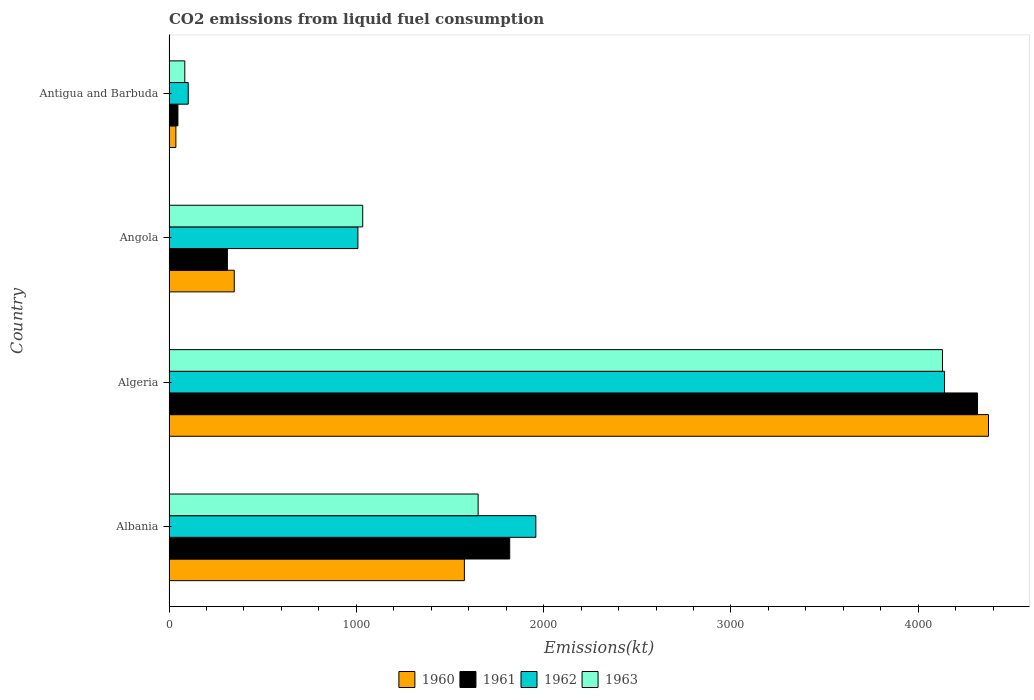How many different coloured bars are there?
Your response must be concise. 4. How many groups of bars are there?
Give a very brief answer. 4. What is the label of the 4th group of bars from the top?
Offer a terse response. Albania. What is the amount of CO2 emitted in 1960 in Albania?
Give a very brief answer. 1576.81. Across all countries, what is the maximum amount of CO2 emitted in 1960?
Your answer should be very brief. 4374.73. Across all countries, what is the minimum amount of CO2 emitted in 1963?
Provide a short and direct response. 84.34. In which country was the amount of CO2 emitted in 1960 maximum?
Keep it short and to the point. Algeria. In which country was the amount of CO2 emitted in 1961 minimum?
Provide a short and direct response. Antigua and Barbuda. What is the total amount of CO2 emitted in 1961 in the graph?
Offer a very short reply. 6494.26. What is the difference between the amount of CO2 emitted in 1961 in Algeria and that in Angola?
Ensure brevity in your answer.  4004.36. What is the difference between the amount of CO2 emitted in 1961 in Albania and the amount of CO2 emitted in 1962 in Angola?
Your response must be concise. 810.41. What is the average amount of CO2 emitted in 1960 per country?
Ensure brevity in your answer.  1584.14. What is the difference between the amount of CO2 emitted in 1960 and amount of CO2 emitted in 1963 in Albania?
Make the answer very short. -73.34. What is the ratio of the amount of CO2 emitted in 1963 in Albania to that in Angola?
Offer a terse response. 1.6. Is the amount of CO2 emitted in 1962 in Albania less than that in Algeria?
Keep it short and to the point. Yes. Is the difference between the amount of CO2 emitted in 1960 in Algeria and Antigua and Barbuda greater than the difference between the amount of CO2 emitted in 1963 in Algeria and Antigua and Barbuda?
Keep it short and to the point. Yes. What is the difference between the highest and the second highest amount of CO2 emitted in 1963?
Offer a terse response. 2478.89. What is the difference between the highest and the lowest amount of CO2 emitted in 1961?
Provide a short and direct response. 4268.39. In how many countries, is the amount of CO2 emitted in 1961 greater than the average amount of CO2 emitted in 1961 taken over all countries?
Provide a succinct answer. 2. What does the 4th bar from the top in Antigua and Barbuda represents?
Your answer should be very brief. 1960. What does the 3rd bar from the bottom in Angola represents?
Your answer should be compact. 1962. How many bars are there?
Provide a succinct answer. 16. Are all the bars in the graph horizontal?
Give a very brief answer. Yes. What is the title of the graph?
Make the answer very short. CO2 emissions from liquid fuel consumption. Does "2003" appear as one of the legend labels in the graph?
Provide a short and direct response. No. What is the label or title of the X-axis?
Make the answer very short. Emissions(kt). What is the Emissions(kt) of 1960 in Albania?
Provide a short and direct response. 1576.81. What is the Emissions(kt) of 1961 in Albania?
Provide a short and direct response. 1818.83. What is the Emissions(kt) in 1962 in Albania?
Your response must be concise. 1958.18. What is the Emissions(kt) of 1963 in Albania?
Offer a terse response. 1650.15. What is the Emissions(kt) in 1960 in Algeria?
Offer a terse response. 4374.73. What is the Emissions(kt) in 1961 in Algeria?
Keep it short and to the point. 4316.06. What is the Emissions(kt) of 1962 in Algeria?
Keep it short and to the point. 4140.04. What is the Emissions(kt) of 1963 in Algeria?
Offer a terse response. 4129.04. What is the Emissions(kt) in 1960 in Angola?
Keep it short and to the point. 348.37. What is the Emissions(kt) in 1961 in Angola?
Offer a very short reply. 311.69. What is the Emissions(kt) in 1962 in Angola?
Give a very brief answer. 1008.42. What is the Emissions(kt) of 1963 in Angola?
Keep it short and to the point. 1034.09. What is the Emissions(kt) in 1960 in Antigua and Barbuda?
Keep it short and to the point. 36.67. What is the Emissions(kt) in 1961 in Antigua and Barbuda?
Keep it short and to the point. 47.67. What is the Emissions(kt) in 1962 in Antigua and Barbuda?
Keep it short and to the point. 102.68. What is the Emissions(kt) of 1963 in Antigua and Barbuda?
Your response must be concise. 84.34. Across all countries, what is the maximum Emissions(kt) of 1960?
Your response must be concise. 4374.73. Across all countries, what is the maximum Emissions(kt) of 1961?
Keep it short and to the point. 4316.06. Across all countries, what is the maximum Emissions(kt) in 1962?
Keep it short and to the point. 4140.04. Across all countries, what is the maximum Emissions(kt) of 1963?
Your answer should be compact. 4129.04. Across all countries, what is the minimum Emissions(kt) of 1960?
Offer a very short reply. 36.67. Across all countries, what is the minimum Emissions(kt) of 1961?
Give a very brief answer. 47.67. Across all countries, what is the minimum Emissions(kt) in 1962?
Your answer should be very brief. 102.68. Across all countries, what is the minimum Emissions(kt) of 1963?
Ensure brevity in your answer.  84.34. What is the total Emissions(kt) in 1960 in the graph?
Ensure brevity in your answer.  6336.58. What is the total Emissions(kt) of 1961 in the graph?
Your answer should be compact. 6494.26. What is the total Emissions(kt) in 1962 in the graph?
Provide a short and direct response. 7209.32. What is the total Emissions(kt) of 1963 in the graph?
Make the answer very short. 6897.63. What is the difference between the Emissions(kt) of 1960 in Albania and that in Algeria?
Offer a very short reply. -2797.92. What is the difference between the Emissions(kt) in 1961 in Albania and that in Algeria?
Provide a succinct answer. -2497.23. What is the difference between the Emissions(kt) of 1962 in Albania and that in Algeria?
Your response must be concise. -2181.86. What is the difference between the Emissions(kt) of 1963 in Albania and that in Algeria?
Make the answer very short. -2478.89. What is the difference between the Emissions(kt) in 1960 in Albania and that in Angola?
Your answer should be very brief. 1228.44. What is the difference between the Emissions(kt) in 1961 in Albania and that in Angola?
Provide a short and direct response. 1507.14. What is the difference between the Emissions(kt) in 1962 in Albania and that in Angola?
Ensure brevity in your answer.  949.75. What is the difference between the Emissions(kt) of 1963 in Albania and that in Angola?
Keep it short and to the point. 616.06. What is the difference between the Emissions(kt) in 1960 in Albania and that in Antigua and Barbuda?
Your answer should be very brief. 1540.14. What is the difference between the Emissions(kt) in 1961 in Albania and that in Antigua and Barbuda?
Offer a very short reply. 1771.16. What is the difference between the Emissions(kt) of 1962 in Albania and that in Antigua and Barbuda?
Offer a terse response. 1855.5. What is the difference between the Emissions(kt) in 1963 in Albania and that in Antigua and Barbuda?
Your response must be concise. 1565.81. What is the difference between the Emissions(kt) of 1960 in Algeria and that in Angola?
Provide a short and direct response. 4026.37. What is the difference between the Emissions(kt) of 1961 in Algeria and that in Angola?
Your answer should be compact. 4004.36. What is the difference between the Emissions(kt) in 1962 in Algeria and that in Angola?
Your answer should be compact. 3131.62. What is the difference between the Emissions(kt) in 1963 in Algeria and that in Angola?
Your answer should be very brief. 3094.95. What is the difference between the Emissions(kt) of 1960 in Algeria and that in Antigua and Barbuda?
Your answer should be very brief. 4338.06. What is the difference between the Emissions(kt) in 1961 in Algeria and that in Antigua and Barbuda?
Offer a very short reply. 4268.39. What is the difference between the Emissions(kt) in 1962 in Algeria and that in Antigua and Barbuda?
Ensure brevity in your answer.  4037.37. What is the difference between the Emissions(kt) of 1963 in Algeria and that in Antigua and Barbuda?
Give a very brief answer. 4044.7. What is the difference between the Emissions(kt) of 1960 in Angola and that in Antigua and Barbuda?
Make the answer very short. 311.69. What is the difference between the Emissions(kt) of 1961 in Angola and that in Antigua and Barbuda?
Your answer should be compact. 264.02. What is the difference between the Emissions(kt) in 1962 in Angola and that in Antigua and Barbuda?
Your answer should be compact. 905.75. What is the difference between the Emissions(kt) in 1963 in Angola and that in Antigua and Barbuda?
Your response must be concise. 949.75. What is the difference between the Emissions(kt) in 1960 in Albania and the Emissions(kt) in 1961 in Algeria?
Offer a terse response. -2739.25. What is the difference between the Emissions(kt) in 1960 in Albania and the Emissions(kt) in 1962 in Algeria?
Offer a very short reply. -2563.23. What is the difference between the Emissions(kt) in 1960 in Albania and the Emissions(kt) in 1963 in Algeria?
Offer a very short reply. -2552.23. What is the difference between the Emissions(kt) of 1961 in Albania and the Emissions(kt) of 1962 in Algeria?
Your answer should be very brief. -2321.21. What is the difference between the Emissions(kt) in 1961 in Albania and the Emissions(kt) in 1963 in Algeria?
Provide a succinct answer. -2310.21. What is the difference between the Emissions(kt) in 1962 in Albania and the Emissions(kt) in 1963 in Algeria?
Make the answer very short. -2170.86. What is the difference between the Emissions(kt) of 1960 in Albania and the Emissions(kt) of 1961 in Angola?
Make the answer very short. 1265.12. What is the difference between the Emissions(kt) in 1960 in Albania and the Emissions(kt) in 1962 in Angola?
Offer a terse response. 568.38. What is the difference between the Emissions(kt) of 1960 in Albania and the Emissions(kt) of 1963 in Angola?
Provide a succinct answer. 542.72. What is the difference between the Emissions(kt) of 1961 in Albania and the Emissions(kt) of 1962 in Angola?
Your answer should be very brief. 810.41. What is the difference between the Emissions(kt) in 1961 in Albania and the Emissions(kt) in 1963 in Angola?
Provide a short and direct response. 784.74. What is the difference between the Emissions(kt) in 1962 in Albania and the Emissions(kt) in 1963 in Angola?
Provide a succinct answer. 924.08. What is the difference between the Emissions(kt) in 1960 in Albania and the Emissions(kt) in 1961 in Antigua and Barbuda?
Keep it short and to the point. 1529.14. What is the difference between the Emissions(kt) in 1960 in Albania and the Emissions(kt) in 1962 in Antigua and Barbuda?
Ensure brevity in your answer.  1474.13. What is the difference between the Emissions(kt) in 1960 in Albania and the Emissions(kt) in 1963 in Antigua and Barbuda?
Your answer should be compact. 1492.47. What is the difference between the Emissions(kt) in 1961 in Albania and the Emissions(kt) in 1962 in Antigua and Barbuda?
Your answer should be compact. 1716.16. What is the difference between the Emissions(kt) of 1961 in Albania and the Emissions(kt) of 1963 in Antigua and Barbuda?
Offer a terse response. 1734.49. What is the difference between the Emissions(kt) of 1962 in Albania and the Emissions(kt) of 1963 in Antigua and Barbuda?
Your answer should be compact. 1873.84. What is the difference between the Emissions(kt) in 1960 in Algeria and the Emissions(kt) in 1961 in Angola?
Provide a short and direct response. 4063.04. What is the difference between the Emissions(kt) in 1960 in Algeria and the Emissions(kt) in 1962 in Angola?
Offer a terse response. 3366.31. What is the difference between the Emissions(kt) of 1960 in Algeria and the Emissions(kt) of 1963 in Angola?
Keep it short and to the point. 3340.64. What is the difference between the Emissions(kt) of 1961 in Algeria and the Emissions(kt) of 1962 in Angola?
Provide a succinct answer. 3307.63. What is the difference between the Emissions(kt) of 1961 in Algeria and the Emissions(kt) of 1963 in Angola?
Offer a very short reply. 3281.97. What is the difference between the Emissions(kt) in 1962 in Algeria and the Emissions(kt) in 1963 in Angola?
Provide a succinct answer. 3105.95. What is the difference between the Emissions(kt) in 1960 in Algeria and the Emissions(kt) in 1961 in Antigua and Barbuda?
Offer a terse response. 4327.06. What is the difference between the Emissions(kt) of 1960 in Algeria and the Emissions(kt) of 1962 in Antigua and Barbuda?
Ensure brevity in your answer.  4272.06. What is the difference between the Emissions(kt) in 1960 in Algeria and the Emissions(kt) in 1963 in Antigua and Barbuda?
Provide a short and direct response. 4290.39. What is the difference between the Emissions(kt) in 1961 in Algeria and the Emissions(kt) in 1962 in Antigua and Barbuda?
Keep it short and to the point. 4213.38. What is the difference between the Emissions(kt) in 1961 in Algeria and the Emissions(kt) in 1963 in Antigua and Barbuda?
Keep it short and to the point. 4231.72. What is the difference between the Emissions(kt) in 1962 in Algeria and the Emissions(kt) in 1963 in Antigua and Barbuda?
Give a very brief answer. 4055.7. What is the difference between the Emissions(kt) of 1960 in Angola and the Emissions(kt) of 1961 in Antigua and Barbuda?
Your response must be concise. 300.69. What is the difference between the Emissions(kt) in 1960 in Angola and the Emissions(kt) in 1962 in Antigua and Barbuda?
Provide a succinct answer. 245.69. What is the difference between the Emissions(kt) in 1960 in Angola and the Emissions(kt) in 1963 in Antigua and Barbuda?
Offer a very short reply. 264.02. What is the difference between the Emissions(kt) in 1961 in Angola and the Emissions(kt) in 1962 in Antigua and Barbuda?
Make the answer very short. 209.02. What is the difference between the Emissions(kt) in 1961 in Angola and the Emissions(kt) in 1963 in Antigua and Barbuda?
Offer a terse response. 227.35. What is the difference between the Emissions(kt) of 1962 in Angola and the Emissions(kt) of 1963 in Antigua and Barbuda?
Keep it short and to the point. 924.08. What is the average Emissions(kt) of 1960 per country?
Provide a short and direct response. 1584.14. What is the average Emissions(kt) in 1961 per country?
Your response must be concise. 1623.56. What is the average Emissions(kt) of 1962 per country?
Ensure brevity in your answer.  1802.33. What is the average Emissions(kt) in 1963 per country?
Your answer should be compact. 1724.41. What is the difference between the Emissions(kt) in 1960 and Emissions(kt) in 1961 in Albania?
Provide a short and direct response. -242.02. What is the difference between the Emissions(kt) in 1960 and Emissions(kt) in 1962 in Albania?
Offer a very short reply. -381.37. What is the difference between the Emissions(kt) in 1960 and Emissions(kt) in 1963 in Albania?
Offer a very short reply. -73.34. What is the difference between the Emissions(kt) in 1961 and Emissions(kt) in 1962 in Albania?
Give a very brief answer. -139.35. What is the difference between the Emissions(kt) of 1961 and Emissions(kt) of 1963 in Albania?
Your response must be concise. 168.68. What is the difference between the Emissions(kt) of 1962 and Emissions(kt) of 1963 in Albania?
Ensure brevity in your answer.  308.03. What is the difference between the Emissions(kt) in 1960 and Emissions(kt) in 1961 in Algeria?
Offer a very short reply. 58.67. What is the difference between the Emissions(kt) of 1960 and Emissions(kt) of 1962 in Algeria?
Make the answer very short. 234.69. What is the difference between the Emissions(kt) in 1960 and Emissions(kt) in 1963 in Algeria?
Offer a terse response. 245.69. What is the difference between the Emissions(kt) in 1961 and Emissions(kt) in 1962 in Algeria?
Offer a very short reply. 176.02. What is the difference between the Emissions(kt) in 1961 and Emissions(kt) in 1963 in Algeria?
Offer a very short reply. 187.02. What is the difference between the Emissions(kt) in 1962 and Emissions(kt) in 1963 in Algeria?
Provide a short and direct response. 11. What is the difference between the Emissions(kt) in 1960 and Emissions(kt) in 1961 in Angola?
Ensure brevity in your answer.  36.67. What is the difference between the Emissions(kt) of 1960 and Emissions(kt) of 1962 in Angola?
Offer a terse response. -660.06. What is the difference between the Emissions(kt) in 1960 and Emissions(kt) in 1963 in Angola?
Provide a succinct answer. -685.73. What is the difference between the Emissions(kt) in 1961 and Emissions(kt) in 1962 in Angola?
Offer a very short reply. -696.73. What is the difference between the Emissions(kt) in 1961 and Emissions(kt) in 1963 in Angola?
Give a very brief answer. -722.4. What is the difference between the Emissions(kt) of 1962 and Emissions(kt) of 1963 in Angola?
Keep it short and to the point. -25.67. What is the difference between the Emissions(kt) of 1960 and Emissions(kt) of 1961 in Antigua and Barbuda?
Keep it short and to the point. -11. What is the difference between the Emissions(kt) in 1960 and Emissions(kt) in 1962 in Antigua and Barbuda?
Offer a very short reply. -66.01. What is the difference between the Emissions(kt) in 1960 and Emissions(kt) in 1963 in Antigua and Barbuda?
Keep it short and to the point. -47.67. What is the difference between the Emissions(kt) in 1961 and Emissions(kt) in 1962 in Antigua and Barbuda?
Provide a short and direct response. -55.01. What is the difference between the Emissions(kt) of 1961 and Emissions(kt) of 1963 in Antigua and Barbuda?
Offer a very short reply. -36.67. What is the difference between the Emissions(kt) of 1962 and Emissions(kt) of 1963 in Antigua and Barbuda?
Your response must be concise. 18.34. What is the ratio of the Emissions(kt) in 1960 in Albania to that in Algeria?
Offer a very short reply. 0.36. What is the ratio of the Emissions(kt) in 1961 in Albania to that in Algeria?
Your response must be concise. 0.42. What is the ratio of the Emissions(kt) of 1962 in Albania to that in Algeria?
Give a very brief answer. 0.47. What is the ratio of the Emissions(kt) of 1963 in Albania to that in Algeria?
Give a very brief answer. 0.4. What is the ratio of the Emissions(kt) in 1960 in Albania to that in Angola?
Provide a succinct answer. 4.53. What is the ratio of the Emissions(kt) of 1961 in Albania to that in Angola?
Offer a very short reply. 5.84. What is the ratio of the Emissions(kt) of 1962 in Albania to that in Angola?
Provide a succinct answer. 1.94. What is the ratio of the Emissions(kt) of 1963 in Albania to that in Angola?
Your answer should be compact. 1.6. What is the ratio of the Emissions(kt) of 1960 in Albania to that in Antigua and Barbuda?
Your answer should be very brief. 43. What is the ratio of the Emissions(kt) of 1961 in Albania to that in Antigua and Barbuda?
Your response must be concise. 38.15. What is the ratio of the Emissions(kt) of 1962 in Albania to that in Antigua and Barbuda?
Offer a very short reply. 19.07. What is the ratio of the Emissions(kt) in 1963 in Albania to that in Antigua and Barbuda?
Offer a very short reply. 19.57. What is the ratio of the Emissions(kt) in 1960 in Algeria to that in Angola?
Make the answer very short. 12.56. What is the ratio of the Emissions(kt) of 1961 in Algeria to that in Angola?
Your response must be concise. 13.85. What is the ratio of the Emissions(kt) of 1962 in Algeria to that in Angola?
Offer a terse response. 4.11. What is the ratio of the Emissions(kt) in 1963 in Algeria to that in Angola?
Your answer should be compact. 3.99. What is the ratio of the Emissions(kt) in 1960 in Algeria to that in Antigua and Barbuda?
Provide a short and direct response. 119.3. What is the ratio of the Emissions(kt) of 1961 in Algeria to that in Antigua and Barbuda?
Your answer should be very brief. 90.54. What is the ratio of the Emissions(kt) in 1962 in Algeria to that in Antigua and Barbuda?
Provide a short and direct response. 40.32. What is the ratio of the Emissions(kt) of 1963 in Algeria to that in Antigua and Barbuda?
Your response must be concise. 48.96. What is the ratio of the Emissions(kt) in 1960 in Angola to that in Antigua and Barbuda?
Offer a terse response. 9.5. What is the ratio of the Emissions(kt) in 1961 in Angola to that in Antigua and Barbuda?
Provide a succinct answer. 6.54. What is the ratio of the Emissions(kt) of 1962 in Angola to that in Antigua and Barbuda?
Your response must be concise. 9.82. What is the ratio of the Emissions(kt) of 1963 in Angola to that in Antigua and Barbuda?
Provide a short and direct response. 12.26. What is the difference between the highest and the second highest Emissions(kt) in 1960?
Your response must be concise. 2797.92. What is the difference between the highest and the second highest Emissions(kt) of 1961?
Give a very brief answer. 2497.23. What is the difference between the highest and the second highest Emissions(kt) in 1962?
Make the answer very short. 2181.86. What is the difference between the highest and the second highest Emissions(kt) in 1963?
Make the answer very short. 2478.89. What is the difference between the highest and the lowest Emissions(kt) in 1960?
Your answer should be compact. 4338.06. What is the difference between the highest and the lowest Emissions(kt) of 1961?
Provide a succinct answer. 4268.39. What is the difference between the highest and the lowest Emissions(kt) in 1962?
Your response must be concise. 4037.37. What is the difference between the highest and the lowest Emissions(kt) in 1963?
Make the answer very short. 4044.7. 